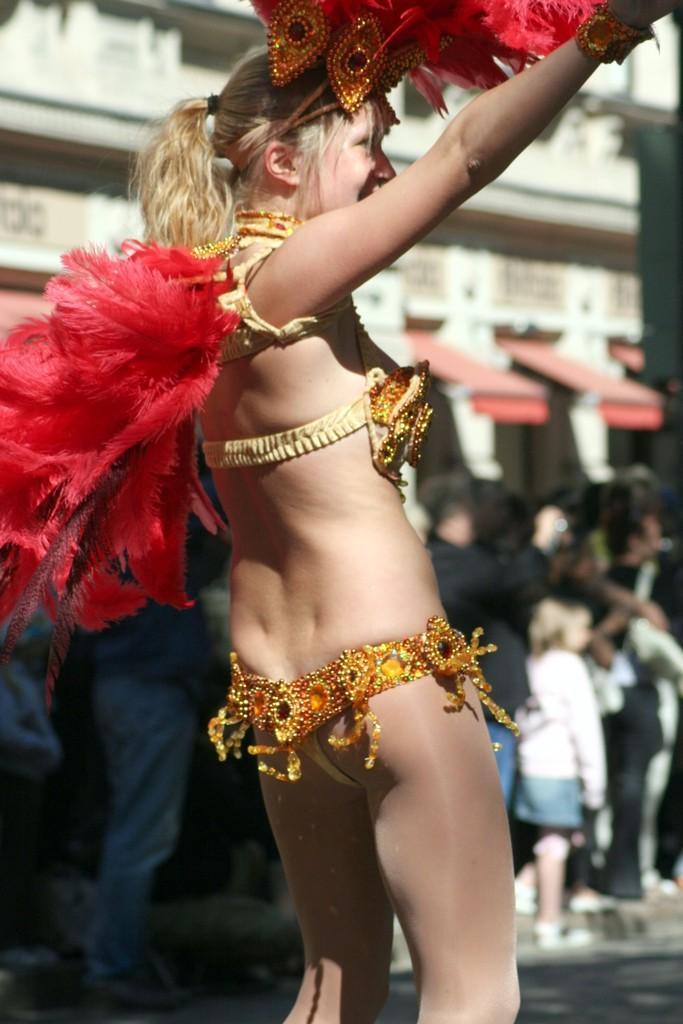Can you describe this image briefly? This image consists of a woman dancing. She is holding feathers. In the background, there are many people. At the bottom, there is a road. 